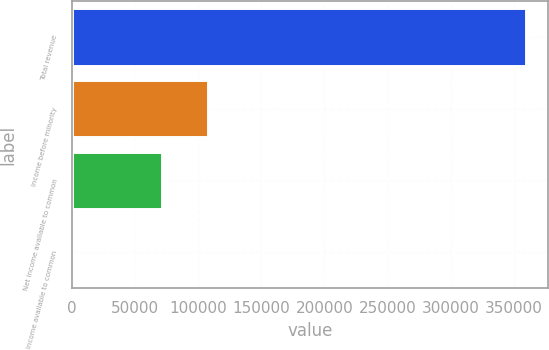Convert chart. <chart><loc_0><loc_0><loc_500><loc_500><bar_chart><fcel>Total revenue<fcel>Income before minority<fcel>Net income available to common<fcel>Income available to common<nl><fcel>359316<fcel>107795<fcel>71863.6<fcel>0.56<nl></chart> 